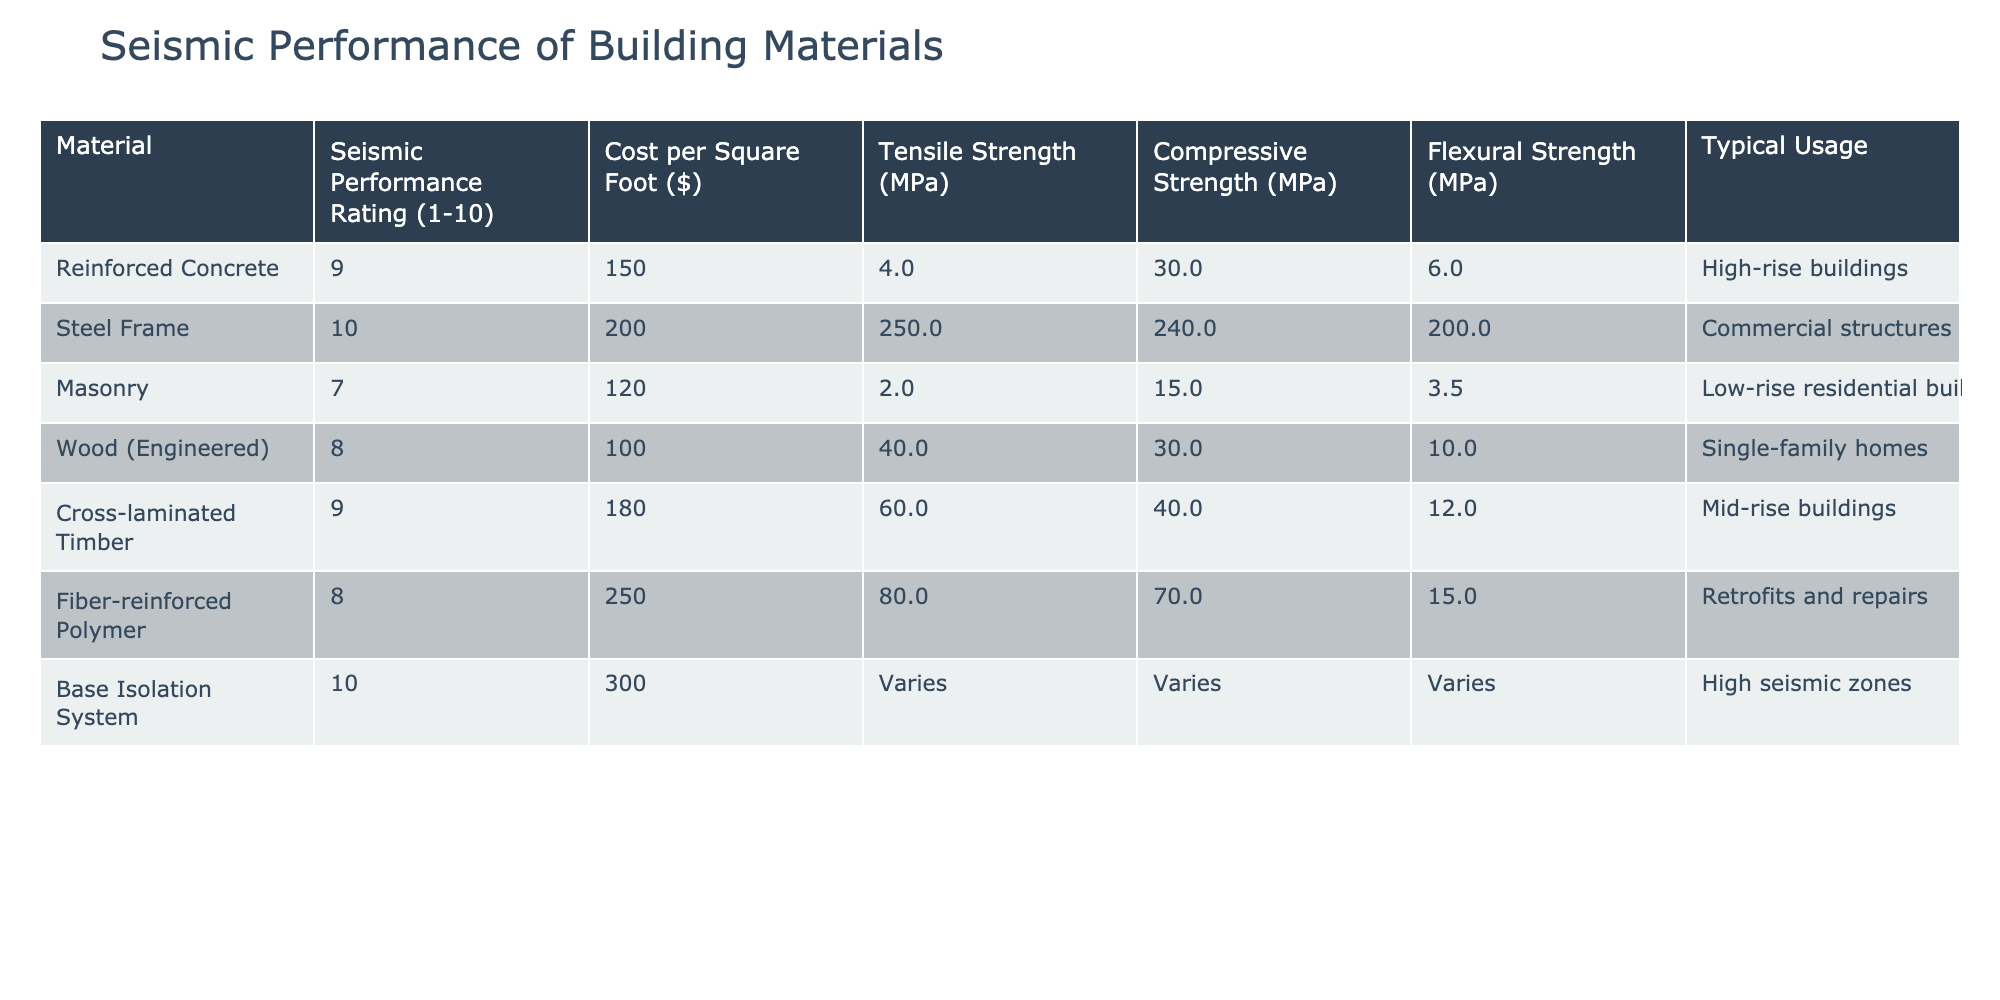What is the Seismic Performance Rating of Steel Frame? The table lists the Seismic Performance Rating for Steel Frame as 10, which is the highest rating in the provided data.
Answer: 10 What is the cost per square foot of Cross-laminated Timber? According to the table, the cost per square foot for Cross-laminated Timber is 180 dollars.
Answer: 180 Which material has the highest compressive strength? A look at the compressive strength values in the table shows that Steel Frame has the highest value at 240 MPa compared to other materials listed.
Answer: Steel Frame Is the Tensile Strength of Wood (Engineered) greater than that of Masonry? The table indicates that the Tensile Strength of Wood (Engineered) is 40.0 MPa, while that of Masonry is 2.0 MPa; hence, it is true that Wood (Engineered) has greater tensile strength.
Answer: Yes What is the average Seismic Performance Rating for the materials listed in the table? The Seismic Performance Ratings are 9, 10, 7, 8, 9, 8, and 10. Adding these ratings gives 61, and there are 7 materials, so the average is 61 divided by 7, which equals approximately 8.71.
Answer: 8.71 Which material is most commonly used in high-rise buildings? The table specifies that Reinforced Concrete is typically used in high-rise buildings.
Answer: Reinforced Concrete What is the total cost per square foot of the lowest cost material and the highest cost material? The lowest cost material is Wood (Engineered) at 100 dollars per square foot, and the highest cost material is Base Isolation System at 300 dollars. Adding these gives a total of 100 + 300 = 400 dollars.
Answer: 400 Compare the Flexural Strength of Fiber-reinforced Polymer and Cross-laminated Timber. The Flexural Strength of Fiber-reinforced Polymer is 15.0 MPa while that of Cross-laminated Timber is 12.0 MPa. Fiber-reinforced Polymer has a higher Flexural Strength by a difference of 3.0 MPa.
Answer: Fiber-reinforced Polymer is stronger Is there any material in the table that has both a Seismic Performance Rating of 10 and is used in high-seismic zones? The Base Isolation System has a Seismic Performance Rating of 10 and is specifically noted for its use in high seismic zones, fulfilling this condition.
Answer: Yes 